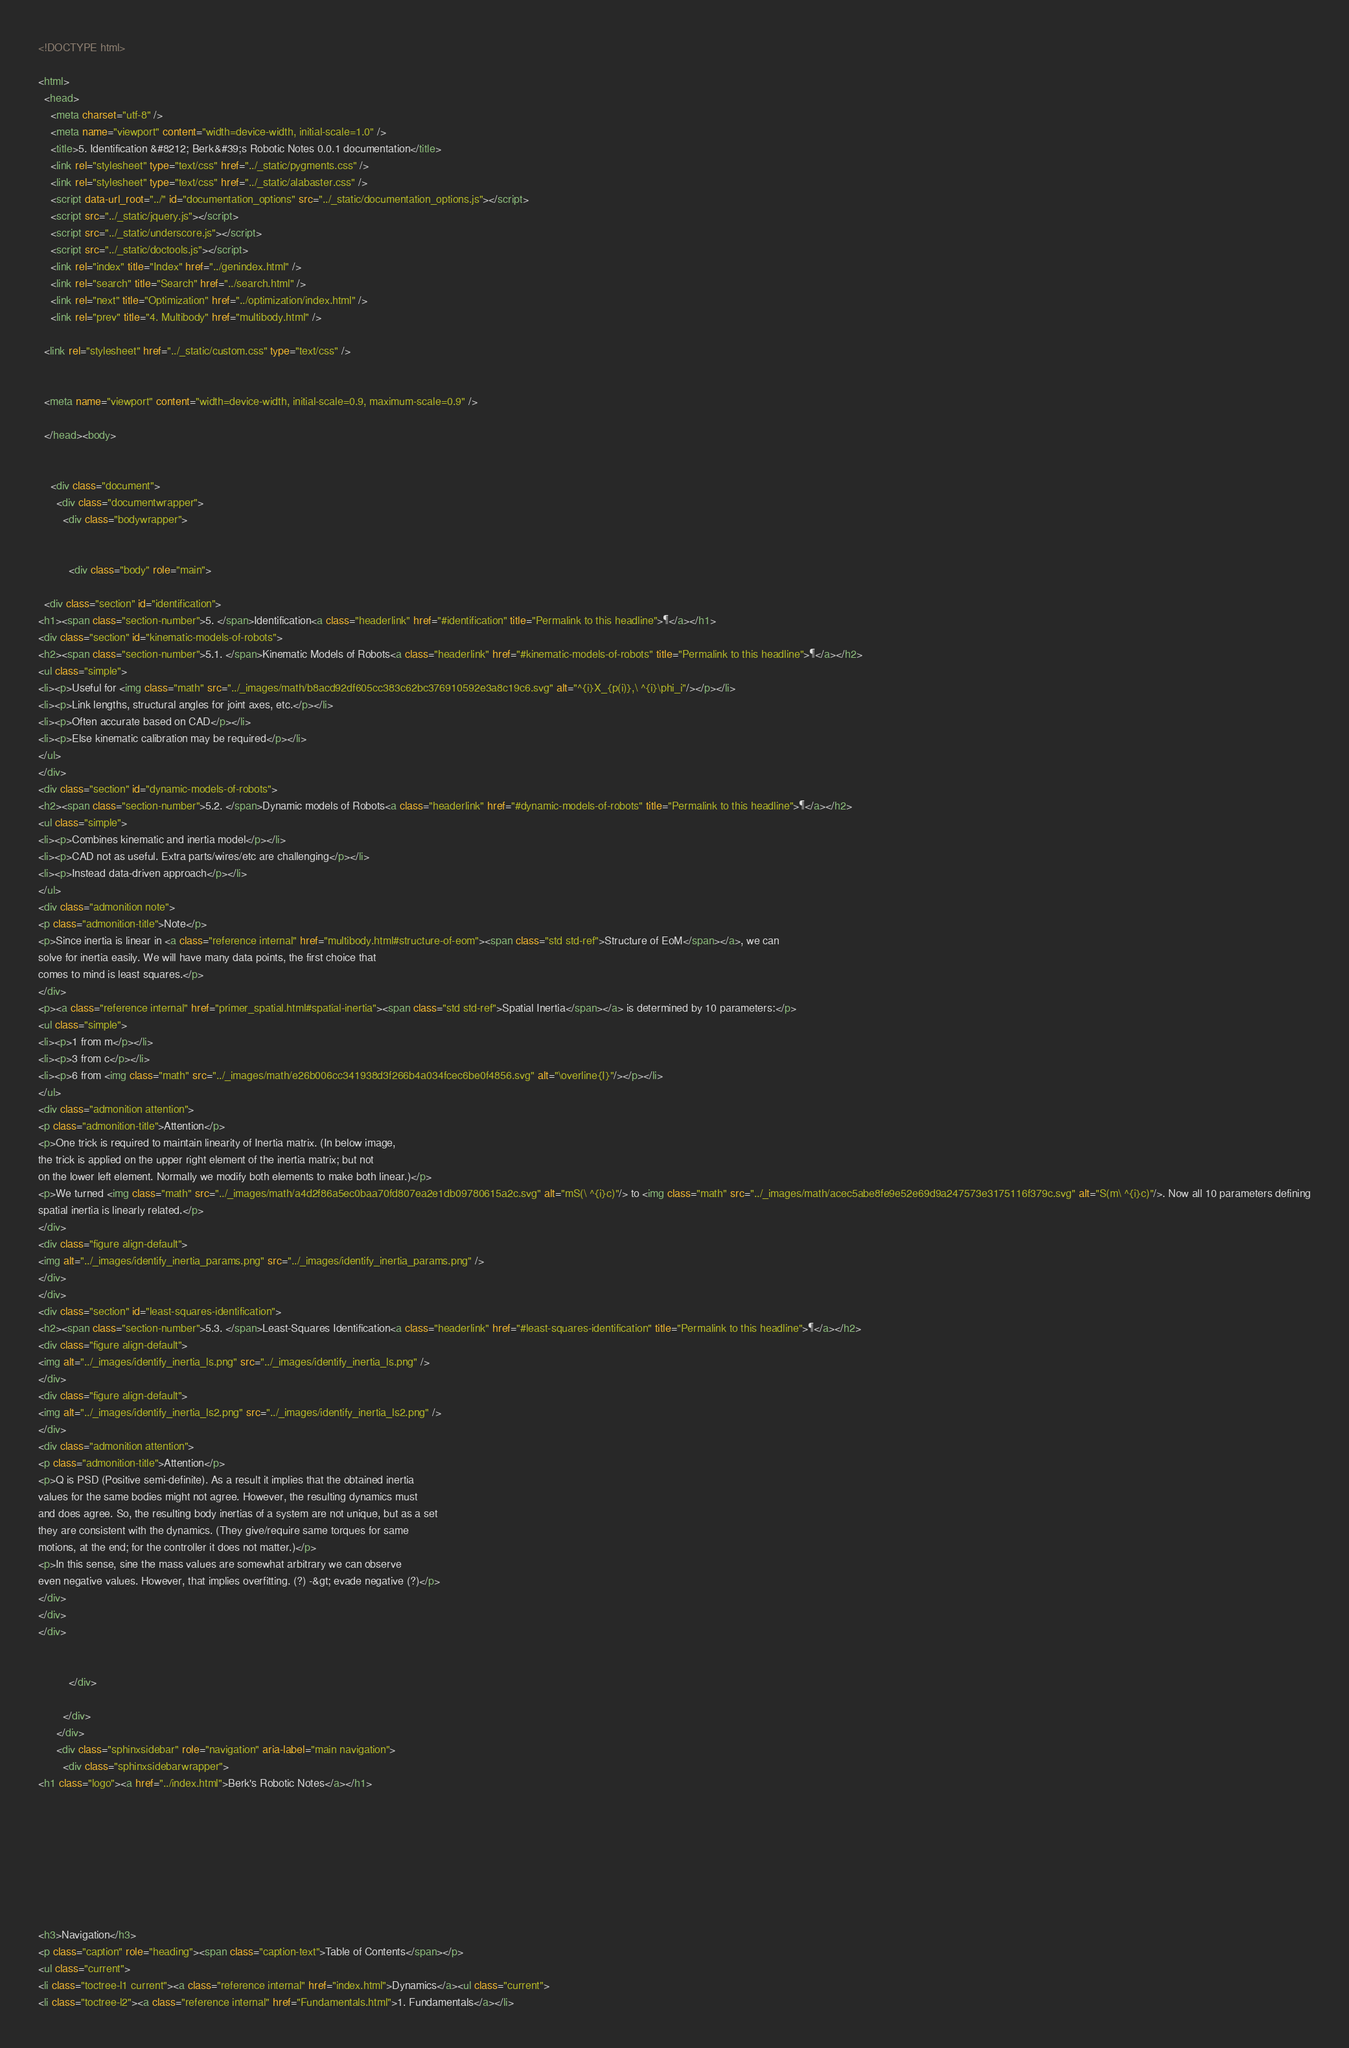Convert code to text. <code><loc_0><loc_0><loc_500><loc_500><_HTML_>
<!DOCTYPE html>

<html>
  <head>
    <meta charset="utf-8" />
    <meta name="viewport" content="width=device-width, initial-scale=1.0" />
    <title>5. Identification &#8212; Berk&#39;s Robotic Notes 0.0.1 documentation</title>
    <link rel="stylesheet" type="text/css" href="../_static/pygments.css" />
    <link rel="stylesheet" type="text/css" href="../_static/alabaster.css" />
    <script data-url_root="../" id="documentation_options" src="../_static/documentation_options.js"></script>
    <script src="../_static/jquery.js"></script>
    <script src="../_static/underscore.js"></script>
    <script src="../_static/doctools.js"></script>
    <link rel="index" title="Index" href="../genindex.html" />
    <link rel="search" title="Search" href="../search.html" />
    <link rel="next" title="Optimization" href="../optimization/index.html" />
    <link rel="prev" title="4. Multibody" href="multibody.html" />
   
  <link rel="stylesheet" href="../_static/custom.css" type="text/css" />
  
  
  <meta name="viewport" content="width=device-width, initial-scale=0.9, maximum-scale=0.9" />

  </head><body>
  

    <div class="document">
      <div class="documentwrapper">
        <div class="bodywrapper">
          

          <div class="body" role="main">
            
  <div class="section" id="identification">
<h1><span class="section-number">5. </span>Identification<a class="headerlink" href="#identification" title="Permalink to this headline">¶</a></h1>
<div class="section" id="kinematic-models-of-robots">
<h2><span class="section-number">5.1. </span>Kinematic Models of Robots<a class="headerlink" href="#kinematic-models-of-robots" title="Permalink to this headline">¶</a></h2>
<ul class="simple">
<li><p>Useful for <img class="math" src="../_images/math/b8acd92df605cc383c62bc376910592e3a8c19c6.svg" alt="^{i}X_{p(i)},\ ^{i}\phi_i"/></p></li>
<li><p>Link lengths, structural angles for joint axes, etc.</p></li>
<li><p>Often accurate based on CAD</p></li>
<li><p>Else kinematic calibration may be required</p></li>
</ul>
</div>
<div class="section" id="dynamic-models-of-robots">
<h2><span class="section-number">5.2. </span>Dynamic models of Robots<a class="headerlink" href="#dynamic-models-of-robots" title="Permalink to this headline">¶</a></h2>
<ul class="simple">
<li><p>Combines kinematic and inertia model</p></li>
<li><p>CAD not as useful. Extra parts/wires/etc are challenging</p></li>
<li><p>Instead data-driven approach</p></li>
</ul>
<div class="admonition note">
<p class="admonition-title">Note</p>
<p>Since inertia is linear in <a class="reference internal" href="multibody.html#structure-of-eom"><span class="std std-ref">Structure of EoM</span></a>, we can
solve for inertia easily. We will have many data points, the first choice that
comes to mind is least squares.</p>
</div>
<p><a class="reference internal" href="primer_spatial.html#spatial-inertia"><span class="std std-ref">Spatial Inertia</span></a> is determined by 10 parameters:</p>
<ul class="simple">
<li><p>1 from m</p></li>
<li><p>3 from c</p></li>
<li><p>6 from <img class="math" src="../_images/math/e26b006cc341938d3f266b4a034fcec6be0f4856.svg" alt="\overline{I}"/></p></li>
</ul>
<div class="admonition attention">
<p class="admonition-title">Attention</p>
<p>One trick is required to maintain linearity of Inertia matrix. (In below image,
the trick is applied on the upper right element of the inertia matrix; but not
on the lower left element. Normally we modify both elements to make both linear.)</p>
<p>We turned <img class="math" src="../_images/math/a4d2f86a5ec0baa70fd807ea2e1db09780615a2c.svg" alt="mS(\ ^{i}c)"/> to <img class="math" src="../_images/math/acec5abe8fe9e52e69d9a247573e3175116f379c.svg" alt="S(m\ ^{i}c)"/>. Now all 10 parameters defining
spatial inertia is linearly related.</p>
</div>
<div class="figure align-default">
<img alt="../_images/identify_inertia_params.png" src="../_images/identify_inertia_params.png" />
</div>
</div>
<div class="section" id="least-squares-identification">
<h2><span class="section-number">5.3. </span>Least-Squares Identification<a class="headerlink" href="#least-squares-identification" title="Permalink to this headline">¶</a></h2>
<div class="figure align-default">
<img alt="../_images/identify_inertia_ls.png" src="../_images/identify_inertia_ls.png" />
</div>
<div class="figure align-default">
<img alt="../_images/identify_inertia_ls2.png" src="../_images/identify_inertia_ls2.png" />
</div>
<div class="admonition attention">
<p class="admonition-title">Attention</p>
<p>Q is PSD (Positive semi-definite). As a result it implies that the obtained inertia
values for the same bodies might not agree. However, the resulting dynamics must
and does agree. So, the resulting body inertias of a system are not unique, but as a set
they are consistent with the dynamics. (They give/require same torques for same
motions, at the end; for the controller it does not matter.)</p>
<p>In this sense, sine the mass values are somewhat arbitrary we can observe
even negative values. However, that implies overfitting. (?) -&gt; evade negative (?)</p>
</div>
</div>
</div>


          </div>
          
        </div>
      </div>
      <div class="sphinxsidebar" role="navigation" aria-label="main navigation">
        <div class="sphinxsidebarwrapper">
<h1 class="logo"><a href="../index.html">Berk's Robotic Notes</a></h1>








<h3>Navigation</h3>
<p class="caption" role="heading"><span class="caption-text">Table of Contents</span></p>
<ul class="current">
<li class="toctree-l1 current"><a class="reference internal" href="index.html">Dynamics</a><ul class="current">
<li class="toctree-l2"><a class="reference internal" href="Fundamentals.html">1. Fundamentals</a></li></code> 